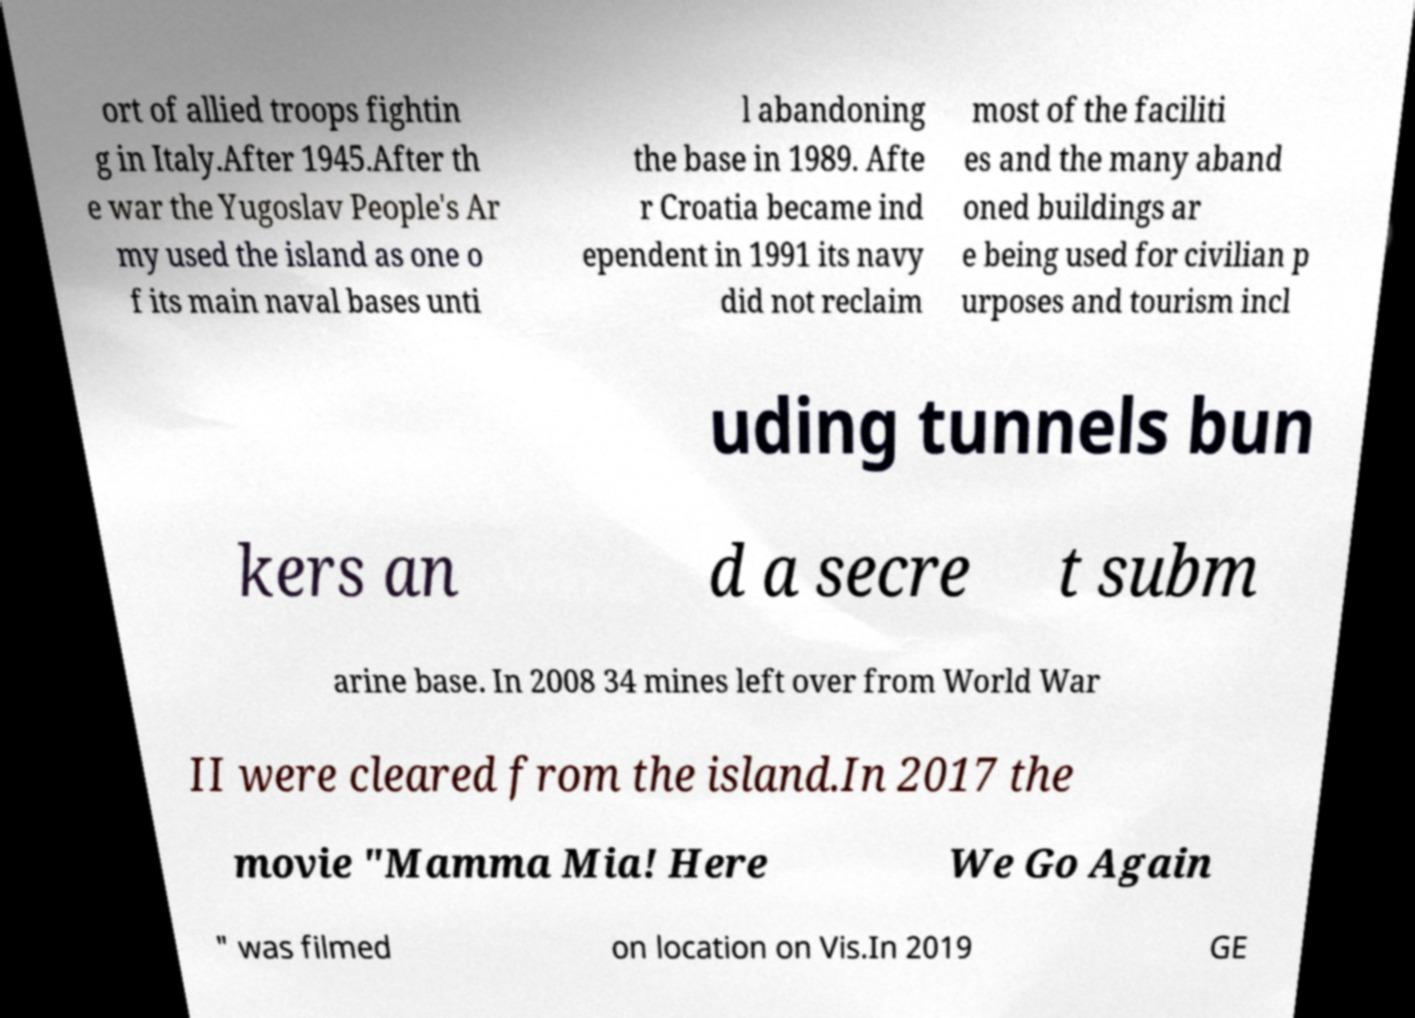What messages or text are displayed in this image? I need them in a readable, typed format. ort of allied troops fightin g in Italy.After 1945.After th e war the Yugoslav People's Ar my used the island as one o f its main naval bases unti l abandoning the base in 1989. Afte r Croatia became ind ependent in 1991 its navy did not reclaim most of the faciliti es and the many aband oned buildings ar e being used for civilian p urposes and tourism incl uding tunnels bun kers an d a secre t subm arine base. In 2008 34 mines left over from World War II were cleared from the island.In 2017 the movie "Mamma Mia! Here We Go Again " was filmed on location on Vis.In 2019 GE 